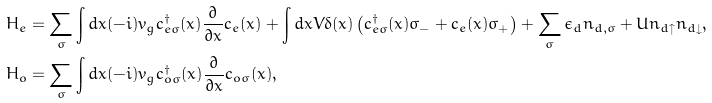Convert formula to latex. <formula><loc_0><loc_0><loc_500><loc_500>H _ { e } & = \sum _ { \sigma } \int d x ( - i ) v _ { g } c _ { e \sigma } ^ { \dagger } ( x ) \frac { \partial } { \partial x } c _ { e } ( x ) + \int d x V \delta ( x ) \left ( c ^ { \dagger } _ { e \sigma } ( x ) \sigma _ { - } + c _ { e } ( x ) \sigma _ { + } \right ) + \sum _ { \sigma } \epsilon _ { d } n _ { d , \sigma } + U n _ { d \uparrow } n _ { d \downarrow } , \\ H _ { o } & = \sum _ { \sigma } \int d x ( - i ) v _ { g } c _ { o \sigma } ^ { \dagger } ( x ) \frac { \partial } { \partial x } c _ { o \sigma } ( x ) ,</formula> 